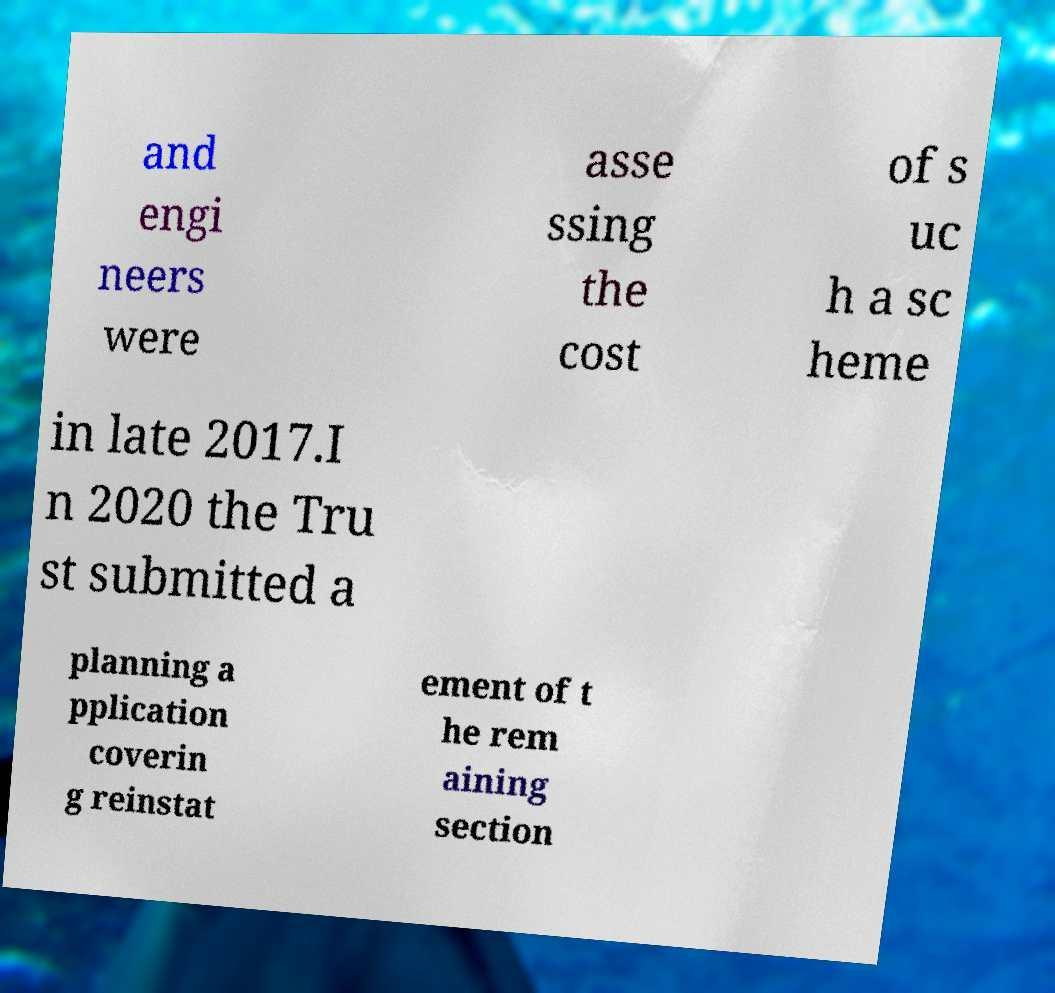Could you extract and type out the text from this image? and engi neers were asse ssing the cost of s uc h a sc heme in late 2017.I n 2020 the Tru st submitted a planning a pplication coverin g reinstat ement of t he rem aining section 